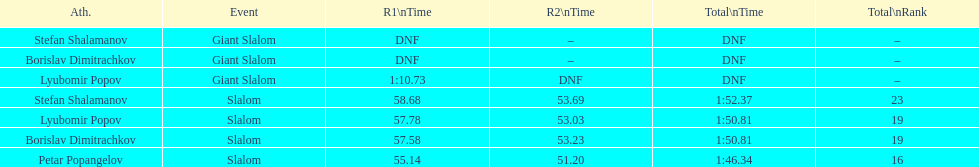Which athlete finished the first race but did not finish the second race? Lyubomir Popov. 